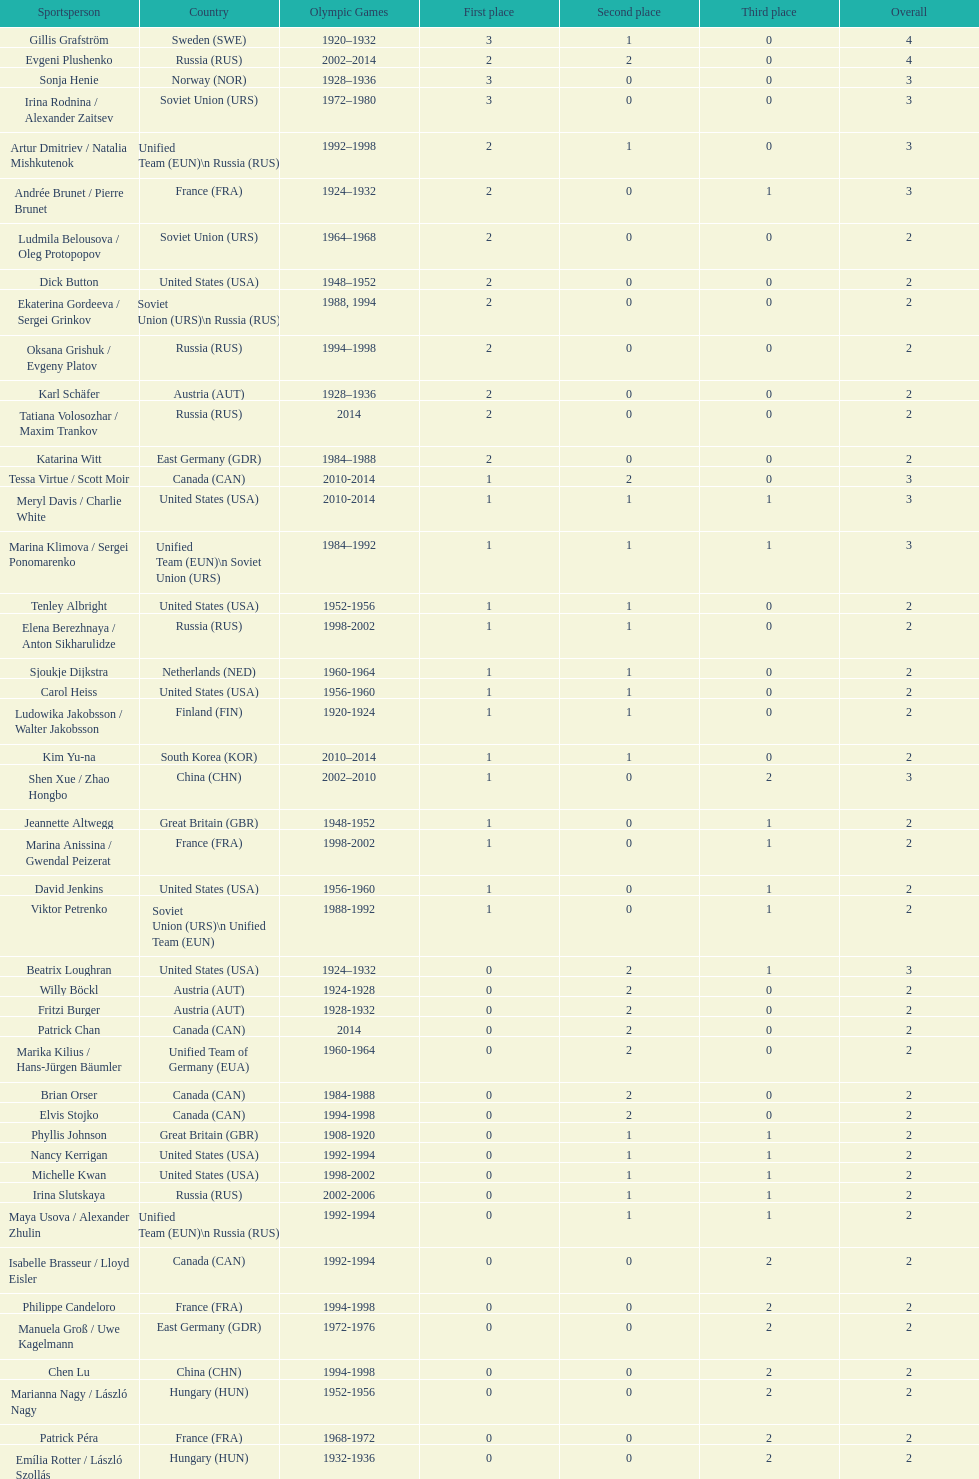Which nation was the first to win three gold medals for olympic figure skating? Sweden. 